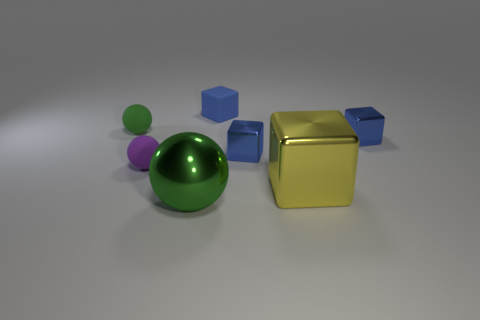There is a tiny matte sphere that is behind the small purple matte object; is it the same color as the large metallic ball?
Your answer should be compact. Yes. Is the number of yellow things that are behind the large sphere greater than the number of blue things in front of the big yellow metallic thing?
Your answer should be very brief. Yes. There is a tiny rubber sphere that is behind the small purple rubber ball; is it the same color as the big object on the left side of the blue rubber cube?
Your answer should be compact. Yes. What is the shape of the blue rubber object that is the same size as the purple rubber object?
Your answer should be very brief. Cube. Is there a purple rubber object that has the same shape as the green rubber object?
Your answer should be very brief. Yes. Is the green ball that is right of the purple object made of the same material as the big thing that is to the right of the small matte block?
Give a very brief answer. Yes. What number of other large spheres have the same material as the purple sphere?
Give a very brief answer. 0. What is the color of the big metal block?
Your answer should be compact. Yellow. There is a green thing right of the purple rubber sphere; does it have the same shape as the green thing behind the big green metallic thing?
Offer a terse response. Yes. The matte object that is to the right of the green metal ball is what color?
Provide a short and direct response. Blue. 